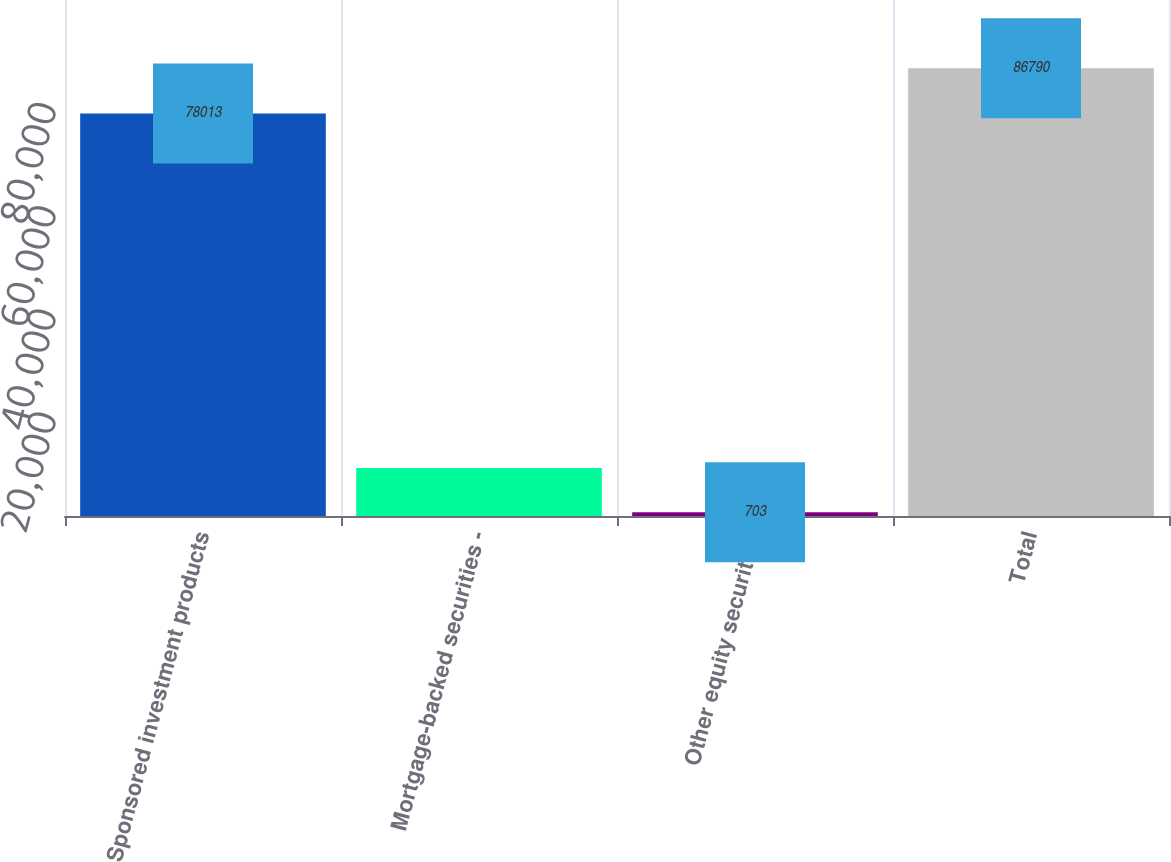<chart> <loc_0><loc_0><loc_500><loc_500><bar_chart><fcel>Sponsored investment products<fcel>Mortgage-backed securities -<fcel>Other equity securities<fcel>Total<nl><fcel>78013<fcel>9311.7<fcel>703<fcel>86790<nl></chart> 